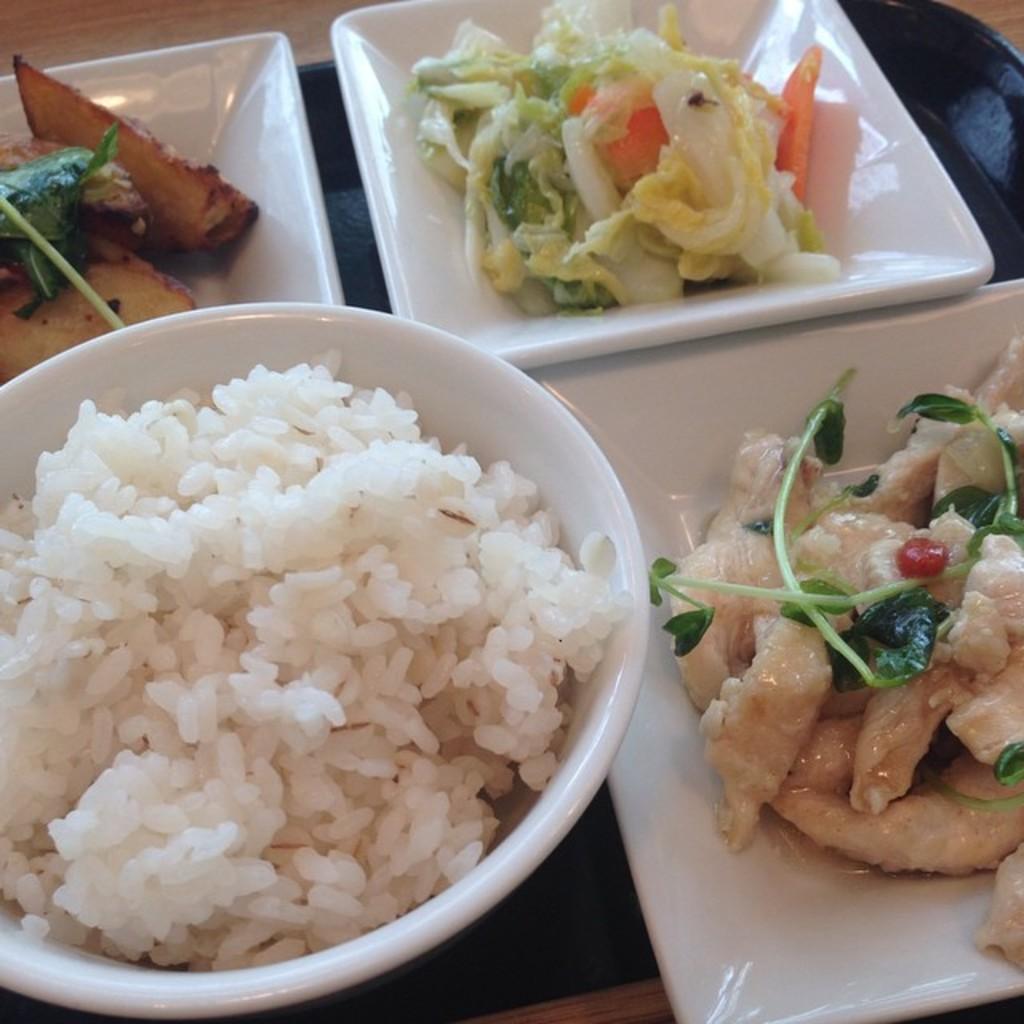Can you describe this image briefly? This is a tray with a bowl of rice, the plates of salad and meat. This tray is placed on the wooden table. 